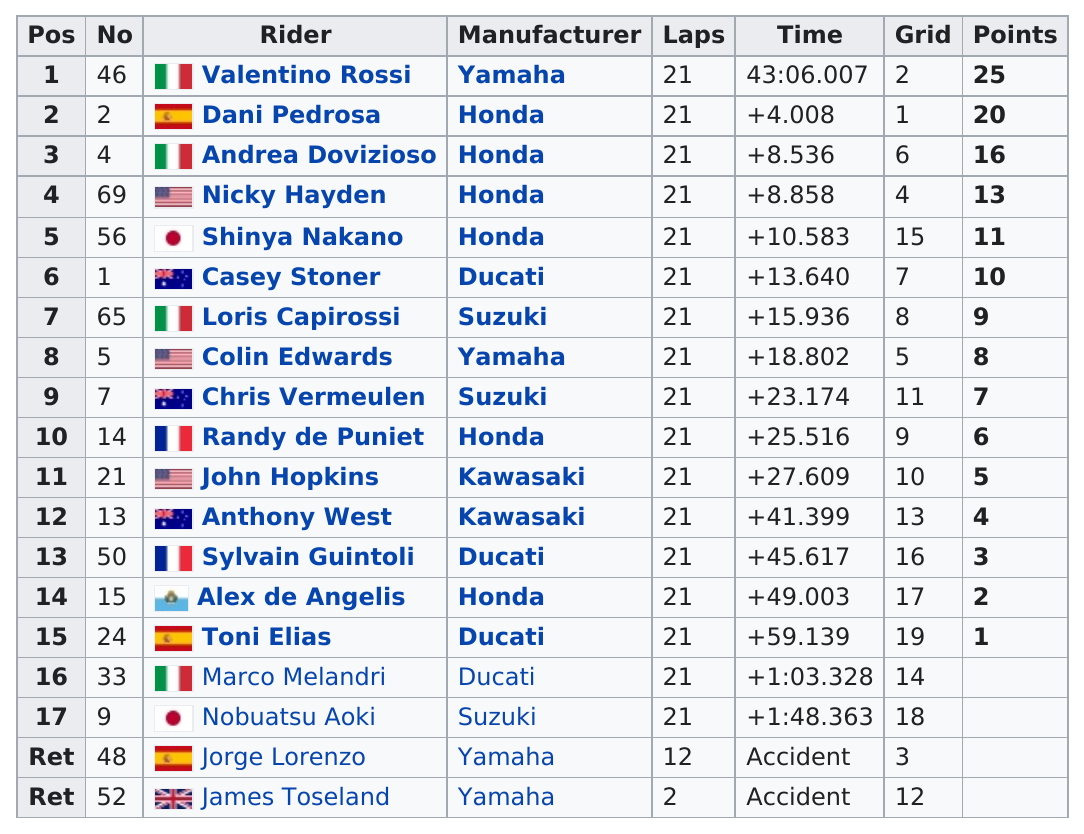Give some essential details in this illustration. Valentino Rossi is the only rider with 25 points, making him a standout in the sport. In the 2008 Malaysian Motorcycle Grand Prix, Dani Pedrosa rode a motorcycle manufactured by Honda, and Loris Capirossi also rode a motorcycle in the same race. In the 2008 Malaysian Motorcycle Grand Prix, John Hopkins placed 10th, with respect to Valentino Rossi. Alex De Angelis finished next after Sylvain Guintoli in the 2008 Malaysian Motorcycle Grand Prix. Valentino Rossi is currently the highest-ranking rider among the group of riders. 